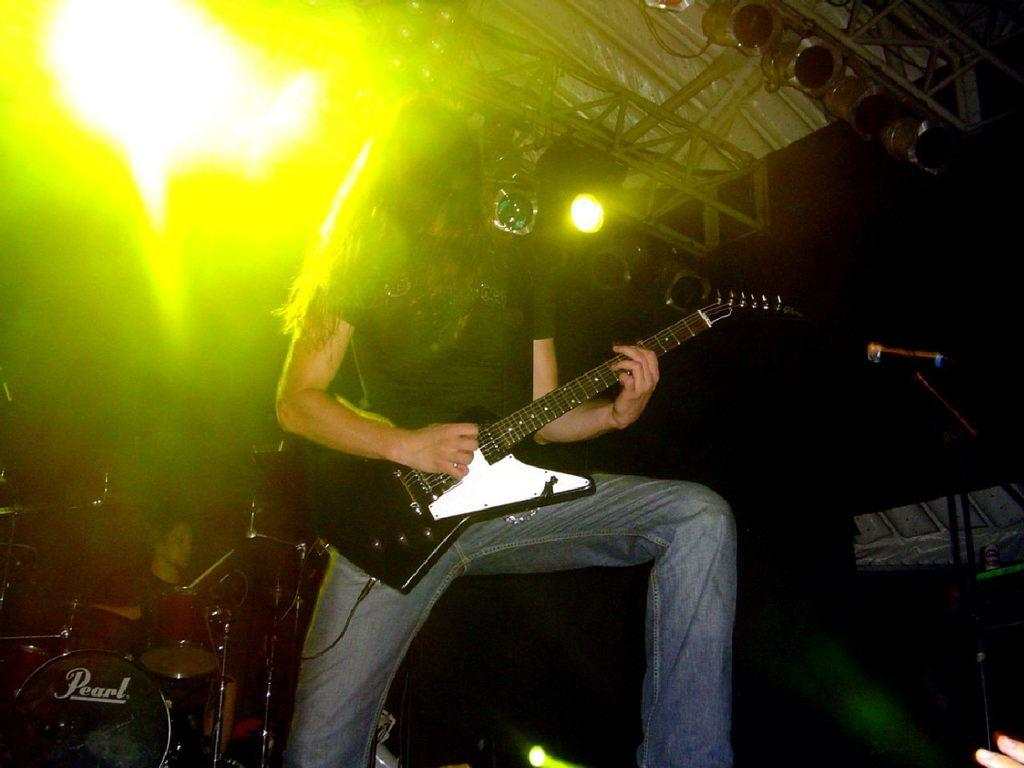What can be seen in the image related to illumination? There are lights in the image. How many people are present in the image? There are two people in the image. What is the woman holding in the image? The woman is holding a guitar. What is the man doing in the image? The man is playing musical drums. Is there a stranger taking a picture of the people playing music in the image? There is no stranger or camera present in the image. What historical event is depicted in the image? The image does not depict any specific historical event; it shows two people playing musical instruments. 